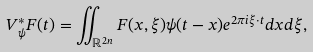Convert formula to latex. <formula><loc_0><loc_0><loc_500><loc_500>V _ { \psi } ^ { * } F ( t ) = \iint _ { \mathbb { R } ^ { 2 n } } F ( x , \xi ) \psi ( t - x ) e ^ { 2 \pi i \xi \cdot t } d x d \xi ,</formula> 